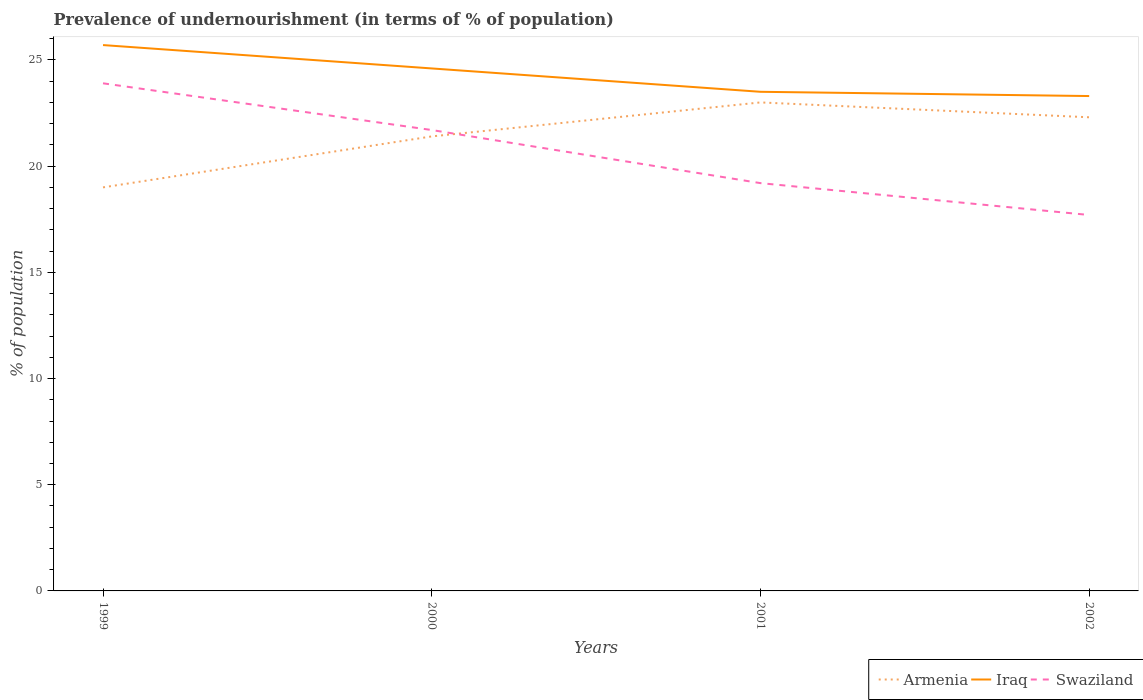How many different coloured lines are there?
Offer a terse response. 3. Does the line corresponding to Armenia intersect with the line corresponding to Swaziland?
Provide a succinct answer. Yes. Across all years, what is the maximum percentage of undernourished population in Iraq?
Keep it short and to the point. 23.3. In which year was the percentage of undernourished population in Iraq maximum?
Keep it short and to the point. 2002. What is the total percentage of undernourished population in Armenia in the graph?
Provide a succinct answer. -0.9. What is the difference between the highest and the second highest percentage of undernourished population in Armenia?
Provide a short and direct response. 4. Is the percentage of undernourished population in Iraq strictly greater than the percentage of undernourished population in Swaziland over the years?
Make the answer very short. No. How many lines are there?
Offer a terse response. 3. Are the values on the major ticks of Y-axis written in scientific E-notation?
Give a very brief answer. No. How are the legend labels stacked?
Your answer should be compact. Horizontal. What is the title of the graph?
Provide a short and direct response. Prevalence of undernourishment (in terms of % of population). Does "Australia" appear as one of the legend labels in the graph?
Offer a terse response. No. What is the label or title of the X-axis?
Give a very brief answer. Years. What is the label or title of the Y-axis?
Keep it short and to the point. % of population. What is the % of population of Iraq in 1999?
Provide a short and direct response. 25.7. What is the % of population in Swaziland in 1999?
Your response must be concise. 23.9. What is the % of population of Armenia in 2000?
Provide a succinct answer. 21.4. What is the % of population of Iraq in 2000?
Make the answer very short. 24.6. What is the % of population of Swaziland in 2000?
Keep it short and to the point. 21.7. What is the % of population of Iraq in 2001?
Provide a short and direct response. 23.5. What is the % of population in Swaziland in 2001?
Keep it short and to the point. 19.2. What is the % of population in Armenia in 2002?
Offer a very short reply. 22.3. What is the % of population in Iraq in 2002?
Provide a short and direct response. 23.3. Across all years, what is the maximum % of population of Armenia?
Give a very brief answer. 23. Across all years, what is the maximum % of population in Iraq?
Give a very brief answer. 25.7. Across all years, what is the maximum % of population in Swaziland?
Provide a succinct answer. 23.9. Across all years, what is the minimum % of population in Armenia?
Your response must be concise. 19. Across all years, what is the minimum % of population of Iraq?
Offer a terse response. 23.3. Across all years, what is the minimum % of population in Swaziland?
Provide a short and direct response. 17.7. What is the total % of population in Armenia in the graph?
Your answer should be compact. 85.7. What is the total % of population of Iraq in the graph?
Provide a short and direct response. 97.1. What is the total % of population of Swaziland in the graph?
Offer a terse response. 82.5. What is the difference between the % of population of Iraq in 1999 and that in 2001?
Your answer should be compact. 2.2. What is the difference between the % of population of Swaziland in 1999 and that in 2002?
Offer a very short reply. 6.2. What is the difference between the % of population in Iraq in 2000 and that in 2001?
Your answer should be very brief. 1.1. What is the difference between the % of population of Armenia in 2000 and that in 2002?
Your answer should be very brief. -0.9. What is the difference between the % of population of Iraq in 2000 and that in 2002?
Keep it short and to the point. 1.3. What is the difference between the % of population in Armenia in 2001 and that in 2002?
Offer a terse response. 0.7. What is the difference between the % of population in Iraq in 2001 and that in 2002?
Offer a very short reply. 0.2. What is the difference between the % of population of Armenia in 1999 and the % of population of Swaziland in 2000?
Your response must be concise. -2.7. What is the difference between the % of population of Armenia in 1999 and the % of population of Iraq in 2002?
Provide a succinct answer. -4.3. What is the difference between the % of population in Armenia in 1999 and the % of population in Swaziland in 2002?
Ensure brevity in your answer.  1.3. What is the difference between the % of population of Iraq in 1999 and the % of population of Swaziland in 2002?
Provide a short and direct response. 8. What is the difference between the % of population of Armenia in 2000 and the % of population of Swaziland in 2001?
Offer a terse response. 2.2. What is the difference between the % of population in Armenia in 2000 and the % of population in Swaziland in 2002?
Provide a succinct answer. 3.7. What is the difference between the % of population in Armenia in 2001 and the % of population in Swaziland in 2002?
Keep it short and to the point. 5.3. What is the average % of population of Armenia per year?
Your response must be concise. 21.43. What is the average % of population of Iraq per year?
Keep it short and to the point. 24.27. What is the average % of population of Swaziland per year?
Provide a short and direct response. 20.62. In the year 1999, what is the difference between the % of population in Armenia and % of population in Iraq?
Give a very brief answer. -6.7. In the year 2001, what is the difference between the % of population of Armenia and % of population of Iraq?
Keep it short and to the point. -0.5. In the year 2001, what is the difference between the % of population in Armenia and % of population in Swaziland?
Provide a short and direct response. 3.8. In the year 2002, what is the difference between the % of population of Armenia and % of population of Iraq?
Your response must be concise. -1. In the year 2002, what is the difference between the % of population of Iraq and % of population of Swaziland?
Provide a succinct answer. 5.6. What is the ratio of the % of population in Armenia in 1999 to that in 2000?
Your response must be concise. 0.89. What is the ratio of the % of population in Iraq in 1999 to that in 2000?
Offer a very short reply. 1.04. What is the ratio of the % of population in Swaziland in 1999 to that in 2000?
Offer a terse response. 1.1. What is the ratio of the % of population of Armenia in 1999 to that in 2001?
Ensure brevity in your answer.  0.83. What is the ratio of the % of population of Iraq in 1999 to that in 2001?
Ensure brevity in your answer.  1.09. What is the ratio of the % of population in Swaziland in 1999 to that in 2001?
Offer a terse response. 1.24. What is the ratio of the % of population of Armenia in 1999 to that in 2002?
Your answer should be very brief. 0.85. What is the ratio of the % of population in Iraq in 1999 to that in 2002?
Give a very brief answer. 1.1. What is the ratio of the % of population in Swaziland in 1999 to that in 2002?
Ensure brevity in your answer.  1.35. What is the ratio of the % of population of Armenia in 2000 to that in 2001?
Offer a very short reply. 0.93. What is the ratio of the % of population of Iraq in 2000 to that in 2001?
Ensure brevity in your answer.  1.05. What is the ratio of the % of population in Swaziland in 2000 to that in 2001?
Keep it short and to the point. 1.13. What is the ratio of the % of population in Armenia in 2000 to that in 2002?
Offer a terse response. 0.96. What is the ratio of the % of population of Iraq in 2000 to that in 2002?
Keep it short and to the point. 1.06. What is the ratio of the % of population of Swaziland in 2000 to that in 2002?
Make the answer very short. 1.23. What is the ratio of the % of population in Armenia in 2001 to that in 2002?
Offer a terse response. 1.03. What is the ratio of the % of population of Iraq in 2001 to that in 2002?
Give a very brief answer. 1.01. What is the ratio of the % of population of Swaziland in 2001 to that in 2002?
Provide a short and direct response. 1.08. What is the difference between the highest and the second highest % of population of Armenia?
Ensure brevity in your answer.  0.7. What is the difference between the highest and the second highest % of population in Iraq?
Give a very brief answer. 1.1. What is the difference between the highest and the lowest % of population in Armenia?
Offer a very short reply. 4. 